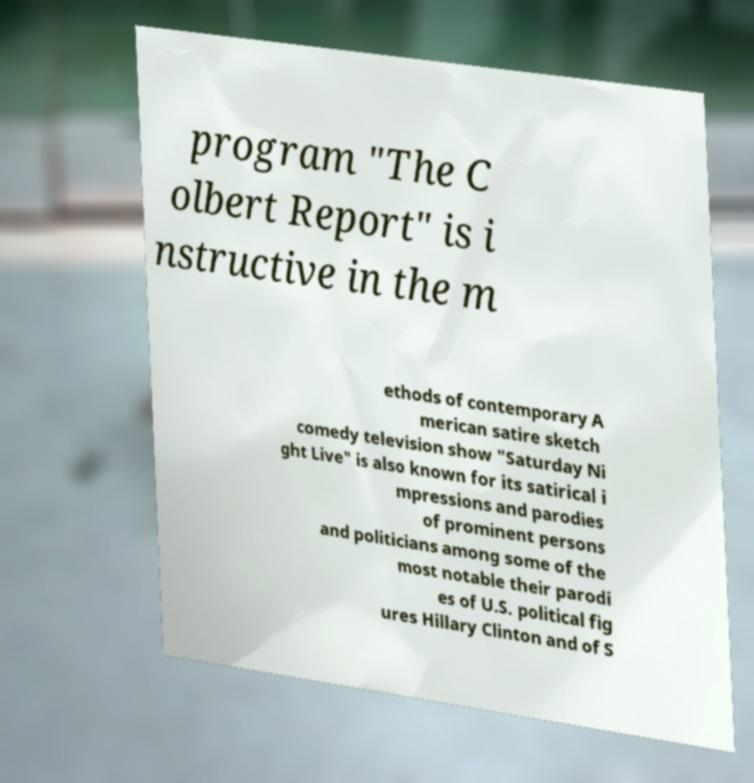Please read and relay the text visible in this image. What does it say? program "The C olbert Report" is i nstructive in the m ethods of contemporary A merican satire sketch comedy television show "Saturday Ni ght Live" is also known for its satirical i mpressions and parodies of prominent persons and politicians among some of the most notable their parodi es of U.S. political fig ures Hillary Clinton and of S 